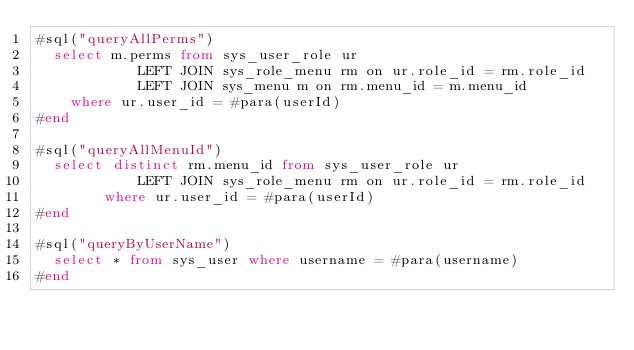Convert code to text. <code><loc_0><loc_0><loc_500><loc_500><_SQL_>#sql("queryAllPerms")
  select m.perms from sys_user_role ur
			LEFT JOIN sys_role_menu rm on ur.role_id = rm.role_id
			LEFT JOIN sys_menu m on rm.menu_id = m.menu_id
	where ur.user_id = #para(userId)
#end

#sql("queryAllMenuId")
  select distinct rm.menu_id from sys_user_role ur
			LEFT JOIN sys_role_menu rm on ur.role_id = rm.role_id
		where ur.user_id = #para(userId)
#end

#sql("queryByUserName")
  select * from sys_user where username = #para(username)
#end</code> 